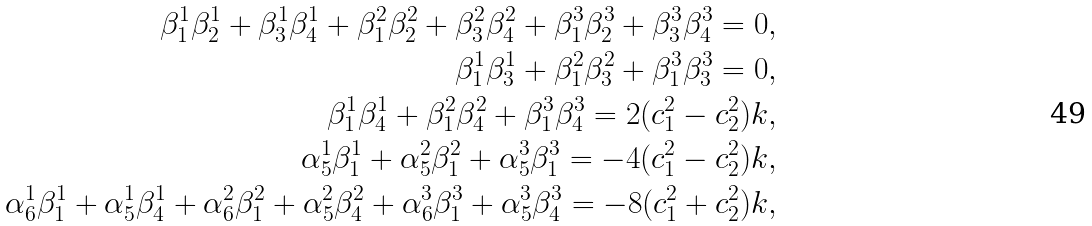<formula> <loc_0><loc_0><loc_500><loc_500>\beta _ { 1 } ^ { 1 } \beta _ { 2 } ^ { 1 } + \beta _ { 3 } ^ { 1 } \beta _ { 4 } ^ { 1 } + \beta _ { 1 } ^ { 2 } \beta _ { 2 } ^ { 2 } + \beta _ { 3 } ^ { 2 } \beta _ { 4 } ^ { 2 } + \beta _ { 1 } ^ { 3 } \beta _ { 2 } ^ { 3 } + \beta _ { 3 } ^ { 3 } \beta _ { 4 } ^ { 3 } = 0 , \\ \beta _ { 1 } ^ { 1 } \beta _ { 3 } ^ { 1 } + \beta _ { 1 } ^ { 2 } \beta _ { 3 } ^ { 2 } + \beta _ { 1 } ^ { 3 } \beta _ { 3 } ^ { 3 } = 0 , \\ \beta _ { 1 } ^ { 1 } \beta _ { 4 } ^ { 1 } + \beta _ { 1 } ^ { 2 } \beta _ { 4 } ^ { 2 } + \beta _ { 1 } ^ { 3 } \beta _ { 4 } ^ { 3 } = 2 ( c _ { 1 } ^ { 2 } - c _ { 2 } ^ { 2 } ) k , \\ \alpha _ { 5 } ^ { 1 } \beta _ { 1 } ^ { 1 } + \alpha _ { 5 } ^ { 2 } \beta _ { 1 } ^ { 2 } + \alpha _ { 5 } ^ { 3 } \beta _ { 1 } ^ { 3 } = - 4 ( c _ { 1 } ^ { 2 } - c _ { 2 } ^ { 2 } ) k , \\ \alpha _ { 6 } ^ { 1 } \beta _ { 1 } ^ { 1 } + \alpha _ { 5 } ^ { 1 } \beta _ { 4 } ^ { 1 } + \alpha _ { 6 } ^ { 2 } \beta _ { 1 } ^ { 2 } + \alpha _ { 5 } ^ { 2 } \beta _ { 4 } ^ { 2 } + \alpha _ { 6 } ^ { 3 } \beta _ { 1 } ^ { 3 } + \alpha _ { 5 } ^ { 3 } \beta _ { 4 } ^ { 3 } = - 8 ( c _ { 1 } ^ { 2 } + c _ { 2 } ^ { 2 } ) k ,</formula> 